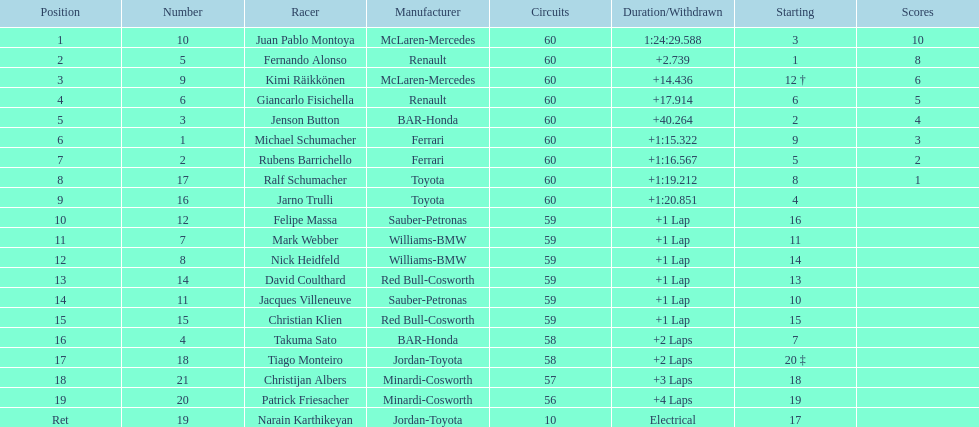Is there a points difference between the 9th position and 19th position on the list? No. 